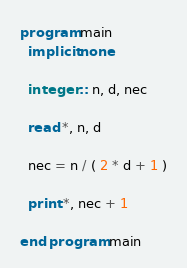Convert code to text. <code><loc_0><loc_0><loc_500><loc_500><_FORTRAN_>program main
  implicit none

  integer :: n, d, nec

  read *, n, d

  nec = n / ( 2 * d + 1 )

  print *, nec + 1

end program main

</code> 